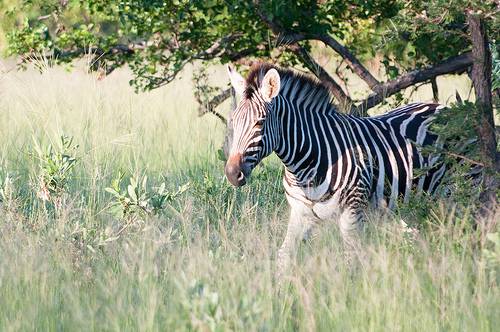Please provide a short description for this region: [0.48, 0.28, 0.71, 0.39]. This region, defined by the coordinates [0.48, 0.28, 0.71, 0.39], contains the zebra's mane, which has a mixture of brown, black, and white colors. 